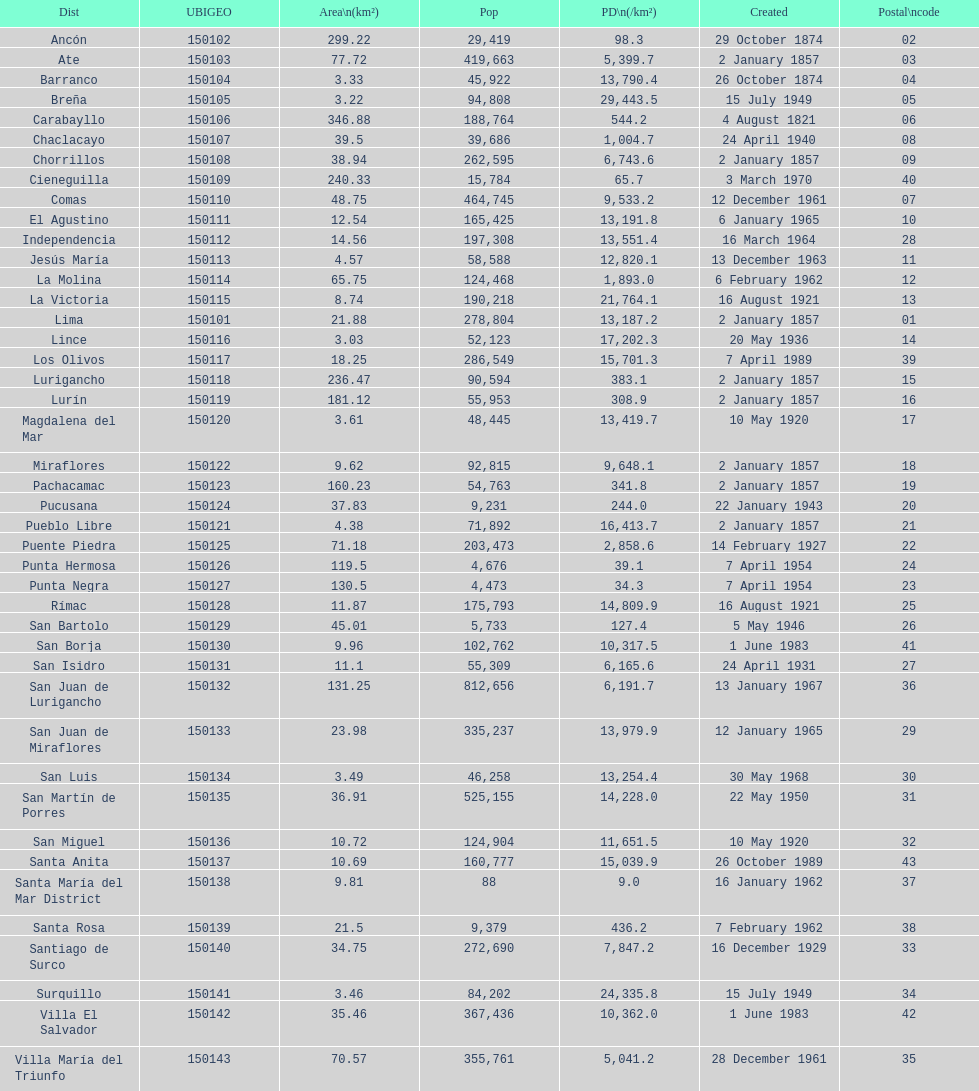What district has the least amount of population? Santa María del Mar District. 